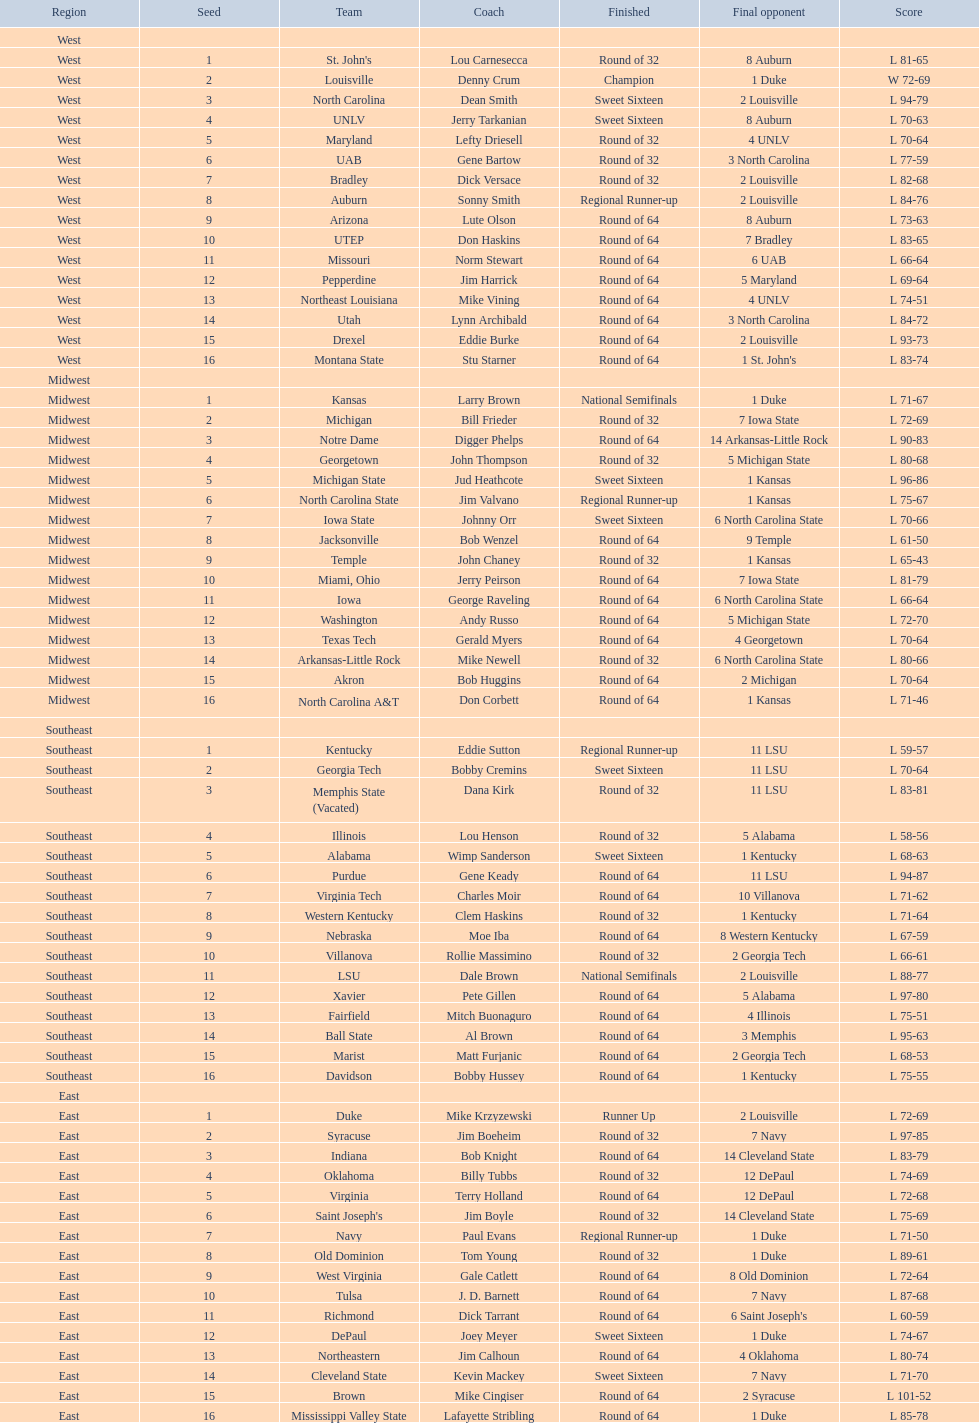I'm looking to parse the entire table for insights. Could you assist me with that? {'header': ['Region', 'Seed', 'Team', 'Coach', 'Finished', 'Final opponent', 'Score'], 'rows': [['West', '', '', '', '', '', ''], ['West', '1', "St. John's", 'Lou Carnesecca', 'Round of 32', '8 Auburn', 'L 81-65'], ['West', '2', 'Louisville', 'Denny Crum', 'Champion', '1 Duke', 'W 72-69'], ['West', '3', 'North Carolina', 'Dean Smith', 'Sweet Sixteen', '2 Louisville', 'L 94-79'], ['West', '4', 'UNLV', 'Jerry Tarkanian', 'Sweet Sixteen', '8 Auburn', 'L 70-63'], ['West', '5', 'Maryland', 'Lefty Driesell', 'Round of 32', '4 UNLV', 'L 70-64'], ['West', '6', 'UAB', 'Gene Bartow', 'Round of 32', '3 North Carolina', 'L 77-59'], ['West', '7', 'Bradley', 'Dick Versace', 'Round of 32', '2 Louisville', 'L 82-68'], ['West', '8', 'Auburn', 'Sonny Smith', 'Regional Runner-up', '2 Louisville', 'L 84-76'], ['West', '9', 'Arizona', 'Lute Olson', 'Round of 64', '8 Auburn', 'L 73-63'], ['West', '10', 'UTEP', 'Don Haskins', 'Round of 64', '7 Bradley', 'L 83-65'], ['West', '11', 'Missouri', 'Norm Stewart', 'Round of 64', '6 UAB', 'L 66-64'], ['West', '12', 'Pepperdine', 'Jim Harrick', 'Round of 64', '5 Maryland', 'L 69-64'], ['West', '13', 'Northeast Louisiana', 'Mike Vining', 'Round of 64', '4 UNLV', 'L 74-51'], ['West', '14', 'Utah', 'Lynn Archibald', 'Round of 64', '3 North Carolina', 'L 84-72'], ['West', '15', 'Drexel', 'Eddie Burke', 'Round of 64', '2 Louisville', 'L 93-73'], ['West', '16', 'Montana State', 'Stu Starner', 'Round of 64', "1 St. John's", 'L 83-74'], ['Midwest', '', '', '', '', '', ''], ['Midwest', '1', 'Kansas', 'Larry Brown', 'National Semifinals', '1 Duke', 'L 71-67'], ['Midwest', '2', 'Michigan', 'Bill Frieder', 'Round of 32', '7 Iowa State', 'L 72-69'], ['Midwest', '3', 'Notre Dame', 'Digger Phelps', 'Round of 64', '14 Arkansas-Little Rock', 'L 90-83'], ['Midwest', '4', 'Georgetown', 'John Thompson', 'Round of 32', '5 Michigan State', 'L 80-68'], ['Midwest', '5', 'Michigan State', 'Jud Heathcote', 'Sweet Sixteen', '1 Kansas', 'L 96-86'], ['Midwest', '6', 'North Carolina State', 'Jim Valvano', 'Regional Runner-up', '1 Kansas', 'L 75-67'], ['Midwest', '7', 'Iowa State', 'Johnny Orr', 'Sweet Sixteen', '6 North Carolina State', 'L 70-66'], ['Midwest', '8', 'Jacksonville', 'Bob Wenzel', 'Round of 64', '9 Temple', 'L 61-50'], ['Midwest', '9', 'Temple', 'John Chaney', 'Round of 32', '1 Kansas', 'L 65-43'], ['Midwest', '10', 'Miami, Ohio', 'Jerry Peirson', 'Round of 64', '7 Iowa State', 'L 81-79'], ['Midwest', '11', 'Iowa', 'George Raveling', 'Round of 64', '6 North Carolina State', 'L 66-64'], ['Midwest', '12', 'Washington', 'Andy Russo', 'Round of 64', '5 Michigan State', 'L 72-70'], ['Midwest', '13', 'Texas Tech', 'Gerald Myers', 'Round of 64', '4 Georgetown', 'L 70-64'], ['Midwest', '14', 'Arkansas-Little Rock', 'Mike Newell', 'Round of 32', '6 North Carolina State', 'L 80-66'], ['Midwest', '15', 'Akron', 'Bob Huggins', 'Round of 64', '2 Michigan', 'L 70-64'], ['Midwest', '16', 'North Carolina A&T', 'Don Corbett', 'Round of 64', '1 Kansas', 'L 71-46'], ['Southeast', '', '', '', '', '', ''], ['Southeast', '1', 'Kentucky', 'Eddie Sutton', 'Regional Runner-up', '11 LSU', 'L 59-57'], ['Southeast', '2', 'Georgia Tech', 'Bobby Cremins', 'Sweet Sixteen', '11 LSU', 'L 70-64'], ['Southeast', '3', 'Memphis State (Vacated)', 'Dana Kirk', 'Round of 32', '11 LSU', 'L 83-81'], ['Southeast', '4', 'Illinois', 'Lou Henson', 'Round of 32', '5 Alabama', 'L 58-56'], ['Southeast', '5', 'Alabama', 'Wimp Sanderson', 'Sweet Sixteen', '1 Kentucky', 'L 68-63'], ['Southeast', '6', 'Purdue', 'Gene Keady', 'Round of 64', '11 LSU', 'L 94-87'], ['Southeast', '7', 'Virginia Tech', 'Charles Moir', 'Round of 64', '10 Villanova', 'L 71-62'], ['Southeast', '8', 'Western Kentucky', 'Clem Haskins', 'Round of 32', '1 Kentucky', 'L 71-64'], ['Southeast', '9', 'Nebraska', 'Moe Iba', 'Round of 64', '8 Western Kentucky', 'L 67-59'], ['Southeast', '10', 'Villanova', 'Rollie Massimino', 'Round of 32', '2 Georgia Tech', 'L 66-61'], ['Southeast', '11', 'LSU', 'Dale Brown', 'National Semifinals', '2 Louisville', 'L 88-77'], ['Southeast', '12', 'Xavier', 'Pete Gillen', 'Round of 64', '5 Alabama', 'L 97-80'], ['Southeast', '13', 'Fairfield', 'Mitch Buonaguro', 'Round of 64', '4 Illinois', 'L 75-51'], ['Southeast', '14', 'Ball State', 'Al Brown', 'Round of 64', '3 Memphis', 'L 95-63'], ['Southeast', '15', 'Marist', 'Matt Furjanic', 'Round of 64', '2 Georgia Tech', 'L 68-53'], ['Southeast', '16', 'Davidson', 'Bobby Hussey', 'Round of 64', '1 Kentucky', 'L 75-55'], ['East', '', '', '', '', '', ''], ['East', '1', 'Duke', 'Mike Krzyzewski', 'Runner Up', '2 Louisville', 'L 72-69'], ['East', '2', 'Syracuse', 'Jim Boeheim', 'Round of 32', '7 Navy', 'L 97-85'], ['East', '3', 'Indiana', 'Bob Knight', 'Round of 64', '14 Cleveland State', 'L 83-79'], ['East', '4', 'Oklahoma', 'Billy Tubbs', 'Round of 32', '12 DePaul', 'L 74-69'], ['East', '5', 'Virginia', 'Terry Holland', 'Round of 64', '12 DePaul', 'L 72-68'], ['East', '6', "Saint Joseph's", 'Jim Boyle', 'Round of 32', '14 Cleveland State', 'L 75-69'], ['East', '7', 'Navy', 'Paul Evans', 'Regional Runner-up', '1 Duke', 'L 71-50'], ['East', '8', 'Old Dominion', 'Tom Young', 'Round of 32', '1 Duke', 'L 89-61'], ['East', '9', 'West Virginia', 'Gale Catlett', 'Round of 64', '8 Old Dominion', 'L 72-64'], ['East', '10', 'Tulsa', 'J. D. Barnett', 'Round of 64', '7 Navy', 'L 87-68'], ['East', '11', 'Richmond', 'Dick Tarrant', 'Round of 64', "6 Saint Joseph's", 'L 60-59'], ['East', '12', 'DePaul', 'Joey Meyer', 'Sweet Sixteen', '1 Duke', 'L 74-67'], ['East', '13', 'Northeastern', 'Jim Calhoun', 'Round of 64', '4 Oklahoma', 'L 80-74'], ['East', '14', 'Cleveland State', 'Kevin Mackey', 'Sweet Sixteen', '7 Navy', 'L 71-70'], ['East', '15', 'Brown', 'Mike Cingiser', 'Round of 64', '2 Syracuse', 'L 101-52'], ['East', '16', 'Mississippi Valley State', 'Lafayette Stribling', 'Round of 64', '1 Duke', 'L 85-78']]} Which is the sole team from the east region to attain the final round? Duke. 